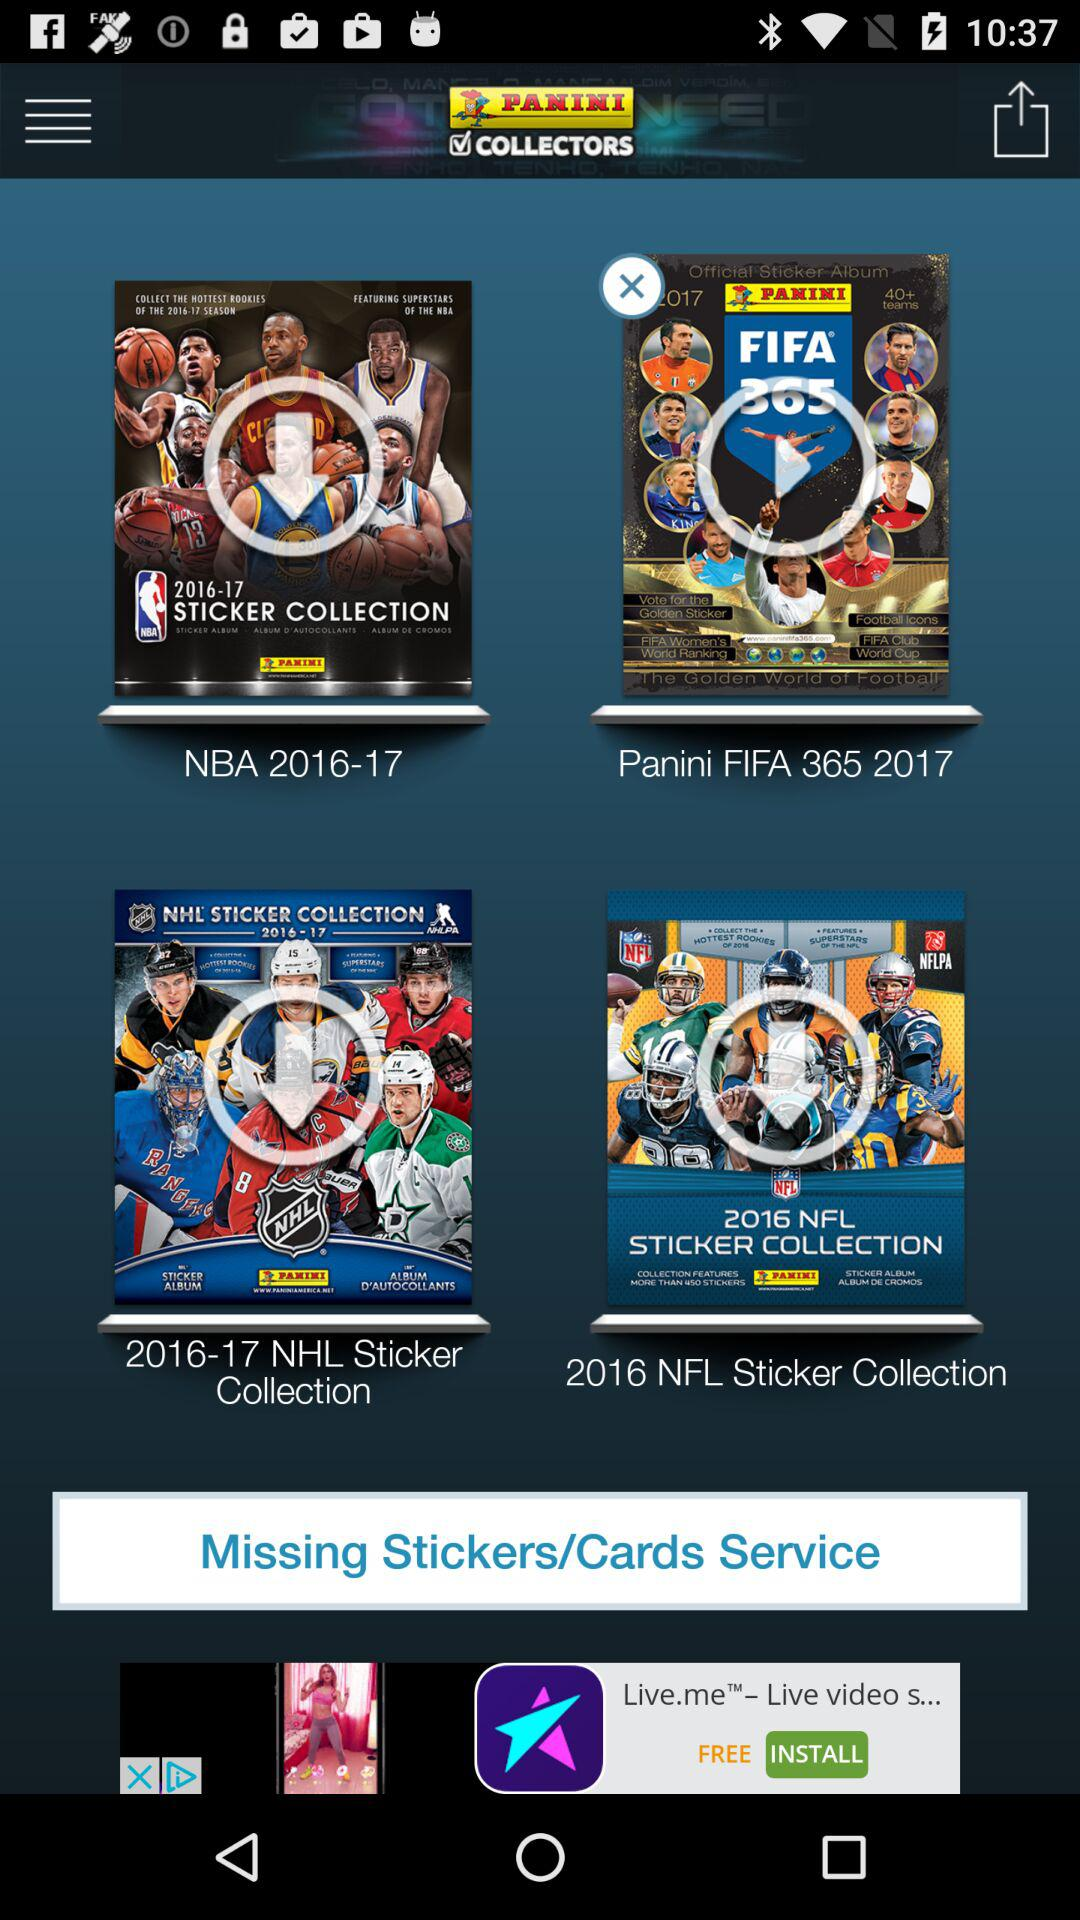How many sticker collections have an x on them?
Answer the question using a single word or phrase. 1 